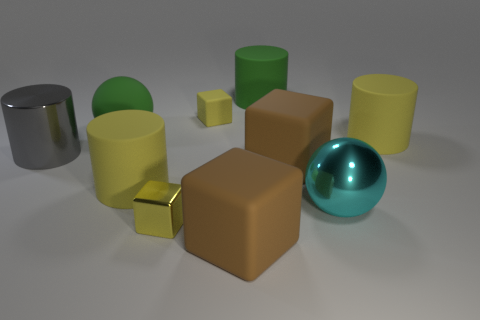Which colors appear most frequently among the objects? The colors that appear most frequently among the objects are shades of yellow and green, which are present in several objects within the image. 